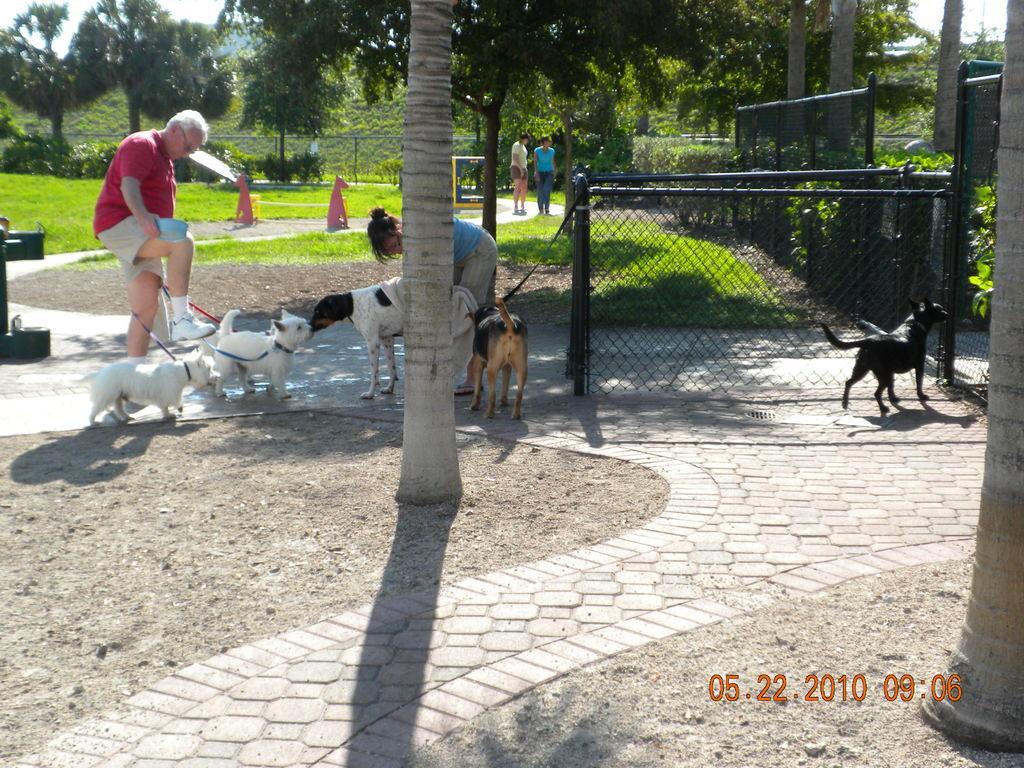Describe this image in one or two sentences. In this picture I can see two persons visible in the middle , in front of persons I can see few animals and trunk of tree and on the right side I can see animals and fence ,trees, persons visible and I can see fence , persons,trees, visible in the middle. 